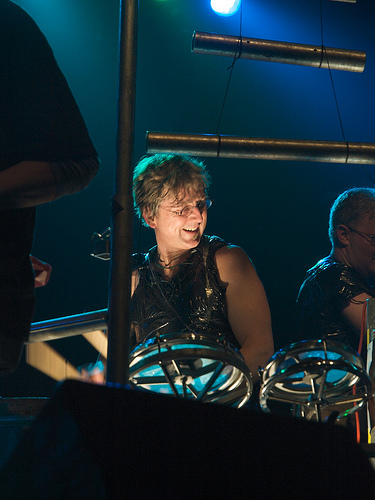<image>
Is the drum behind the man? No. The drum is not behind the man. From this viewpoint, the drum appears to be positioned elsewhere in the scene. Is the person in front of the pole? No. The person is not in front of the pole. The spatial positioning shows a different relationship between these objects. 